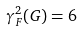<formula> <loc_0><loc_0><loc_500><loc_500>\gamma _ { F } ^ { 2 } ( G ) = 6</formula> 